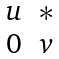<formula> <loc_0><loc_0><loc_500><loc_500>\begin{matrix} u & \ast \\ 0 & v \end{matrix}</formula> 